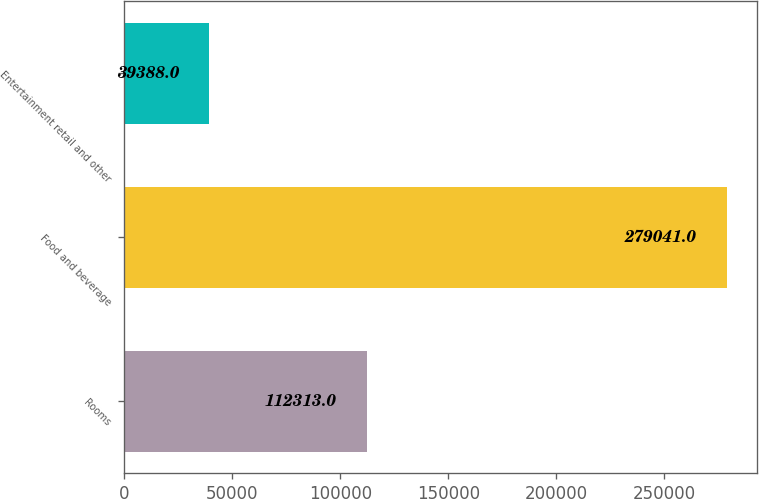<chart> <loc_0><loc_0><loc_500><loc_500><bar_chart><fcel>Rooms<fcel>Food and beverage<fcel>Entertainment retail and other<nl><fcel>112313<fcel>279041<fcel>39388<nl></chart> 